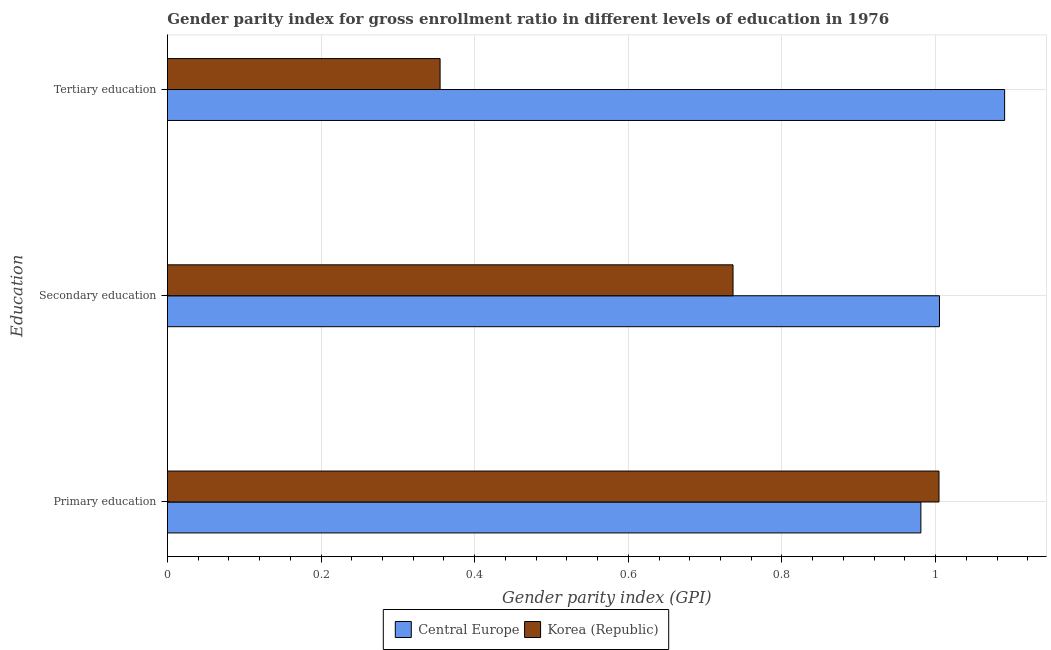How many different coloured bars are there?
Your answer should be compact. 2. How many groups of bars are there?
Make the answer very short. 3. Are the number of bars per tick equal to the number of legend labels?
Provide a short and direct response. Yes. Are the number of bars on each tick of the Y-axis equal?
Your answer should be compact. Yes. What is the label of the 1st group of bars from the top?
Make the answer very short. Tertiary education. What is the gender parity index in primary education in Korea (Republic)?
Your answer should be very brief. 1. Across all countries, what is the maximum gender parity index in tertiary education?
Provide a short and direct response. 1.09. Across all countries, what is the minimum gender parity index in secondary education?
Offer a very short reply. 0.74. In which country was the gender parity index in secondary education maximum?
Make the answer very short. Central Europe. In which country was the gender parity index in primary education minimum?
Keep it short and to the point. Central Europe. What is the total gender parity index in secondary education in the graph?
Offer a very short reply. 1.74. What is the difference between the gender parity index in primary education in Central Europe and that in Korea (Republic)?
Provide a succinct answer. -0.02. What is the difference between the gender parity index in tertiary education in Korea (Republic) and the gender parity index in secondary education in Central Europe?
Give a very brief answer. -0.65. What is the average gender parity index in primary education per country?
Keep it short and to the point. 0.99. What is the difference between the gender parity index in tertiary education and gender parity index in primary education in Korea (Republic)?
Give a very brief answer. -0.65. What is the ratio of the gender parity index in tertiary education in Central Europe to that in Korea (Republic)?
Your response must be concise. 3.07. Is the difference between the gender parity index in secondary education in Korea (Republic) and Central Europe greater than the difference between the gender parity index in primary education in Korea (Republic) and Central Europe?
Offer a terse response. No. What is the difference between the highest and the second highest gender parity index in tertiary education?
Offer a very short reply. 0.73. What is the difference between the highest and the lowest gender parity index in secondary education?
Offer a terse response. 0.27. Is the sum of the gender parity index in secondary education in Korea (Republic) and Central Europe greater than the maximum gender parity index in primary education across all countries?
Offer a terse response. Yes. What does the 2nd bar from the top in Secondary education represents?
Your response must be concise. Central Europe. Is it the case that in every country, the sum of the gender parity index in primary education and gender parity index in secondary education is greater than the gender parity index in tertiary education?
Your answer should be very brief. Yes. How many bars are there?
Offer a terse response. 6. Are the values on the major ticks of X-axis written in scientific E-notation?
Make the answer very short. No. Does the graph contain grids?
Your answer should be compact. Yes. Where does the legend appear in the graph?
Offer a very short reply. Bottom center. How are the legend labels stacked?
Provide a succinct answer. Horizontal. What is the title of the graph?
Provide a succinct answer. Gender parity index for gross enrollment ratio in different levels of education in 1976. Does "Argentina" appear as one of the legend labels in the graph?
Offer a terse response. No. What is the label or title of the X-axis?
Your response must be concise. Gender parity index (GPI). What is the label or title of the Y-axis?
Keep it short and to the point. Education. What is the Gender parity index (GPI) in Central Europe in Primary education?
Offer a very short reply. 0.98. What is the Gender parity index (GPI) of Korea (Republic) in Primary education?
Your answer should be very brief. 1. What is the Gender parity index (GPI) in Central Europe in Secondary education?
Provide a succinct answer. 1.01. What is the Gender parity index (GPI) in Korea (Republic) in Secondary education?
Keep it short and to the point. 0.74. What is the Gender parity index (GPI) of Central Europe in Tertiary education?
Keep it short and to the point. 1.09. What is the Gender parity index (GPI) in Korea (Republic) in Tertiary education?
Your answer should be very brief. 0.35. Across all Education, what is the maximum Gender parity index (GPI) in Central Europe?
Provide a short and direct response. 1.09. Across all Education, what is the maximum Gender parity index (GPI) in Korea (Republic)?
Your response must be concise. 1. Across all Education, what is the minimum Gender parity index (GPI) of Central Europe?
Offer a very short reply. 0.98. Across all Education, what is the minimum Gender parity index (GPI) in Korea (Republic)?
Offer a very short reply. 0.35. What is the total Gender parity index (GPI) of Central Europe in the graph?
Ensure brevity in your answer.  3.08. What is the total Gender parity index (GPI) in Korea (Republic) in the graph?
Offer a very short reply. 2.1. What is the difference between the Gender parity index (GPI) in Central Europe in Primary education and that in Secondary education?
Your answer should be very brief. -0.02. What is the difference between the Gender parity index (GPI) in Korea (Republic) in Primary education and that in Secondary education?
Make the answer very short. 0.27. What is the difference between the Gender parity index (GPI) of Central Europe in Primary education and that in Tertiary education?
Your answer should be very brief. -0.11. What is the difference between the Gender parity index (GPI) in Korea (Republic) in Primary education and that in Tertiary education?
Your answer should be very brief. 0.65. What is the difference between the Gender parity index (GPI) in Central Europe in Secondary education and that in Tertiary education?
Give a very brief answer. -0.08. What is the difference between the Gender parity index (GPI) of Korea (Republic) in Secondary education and that in Tertiary education?
Ensure brevity in your answer.  0.38. What is the difference between the Gender parity index (GPI) of Central Europe in Primary education and the Gender parity index (GPI) of Korea (Republic) in Secondary education?
Provide a short and direct response. 0.24. What is the difference between the Gender parity index (GPI) of Central Europe in Primary education and the Gender parity index (GPI) of Korea (Republic) in Tertiary education?
Keep it short and to the point. 0.63. What is the difference between the Gender parity index (GPI) in Central Europe in Secondary education and the Gender parity index (GPI) in Korea (Republic) in Tertiary education?
Your answer should be compact. 0.65. What is the average Gender parity index (GPI) in Central Europe per Education?
Your response must be concise. 1.03. What is the average Gender parity index (GPI) in Korea (Republic) per Education?
Ensure brevity in your answer.  0.7. What is the difference between the Gender parity index (GPI) of Central Europe and Gender parity index (GPI) of Korea (Republic) in Primary education?
Your answer should be very brief. -0.02. What is the difference between the Gender parity index (GPI) of Central Europe and Gender parity index (GPI) of Korea (Republic) in Secondary education?
Your answer should be very brief. 0.27. What is the difference between the Gender parity index (GPI) in Central Europe and Gender parity index (GPI) in Korea (Republic) in Tertiary education?
Your answer should be compact. 0.73. What is the ratio of the Gender parity index (GPI) in Central Europe in Primary education to that in Secondary education?
Offer a terse response. 0.98. What is the ratio of the Gender parity index (GPI) in Korea (Republic) in Primary education to that in Secondary education?
Make the answer very short. 1.36. What is the ratio of the Gender parity index (GPI) in Korea (Republic) in Primary education to that in Tertiary education?
Make the answer very short. 2.83. What is the ratio of the Gender parity index (GPI) of Central Europe in Secondary education to that in Tertiary education?
Provide a short and direct response. 0.92. What is the ratio of the Gender parity index (GPI) of Korea (Republic) in Secondary education to that in Tertiary education?
Your response must be concise. 2.07. What is the difference between the highest and the second highest Gender parity index (GPI) in Central Europe?
Provide a short and direct response. 0.08. What is the difference between the highest and the second highest Gender parity index (GPI) of Korea (Republic)?
Offer a terse response. 0.27. What is the difference between the highest and the lowest Gender parity index (GPI) in Central Europe?
Provide a short and direct response. 0.11. What is the difference between the highest and the lowest Gender parity index (GPI) of Korea (Republic)?
Your answer should be compact. 0.65. 